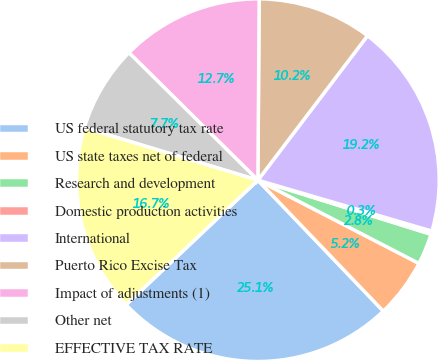Convert chart. <chart><loc_0><loc_0><loc_500><loc_500><pie_chart><fcel>US federal statutory tax rate<fcel>US state taxes net of federal<fcel>Research and development<fcel>Domestic production activities<fcel>International<fcel>Puerto Rico Excise Tax<fcel>Impact of adjustments (1)<fcel>Other net<fcel>EFFECTIVE TAX RATE<nl><fcel>25.11%<fcel>5.25%<fcel>2.77%<fcel>0.29%<fcel>19.2%<fcel>10.22%<fcel>12.7%<fcel>7.74%<fcel>16.72%<nl></chart> 